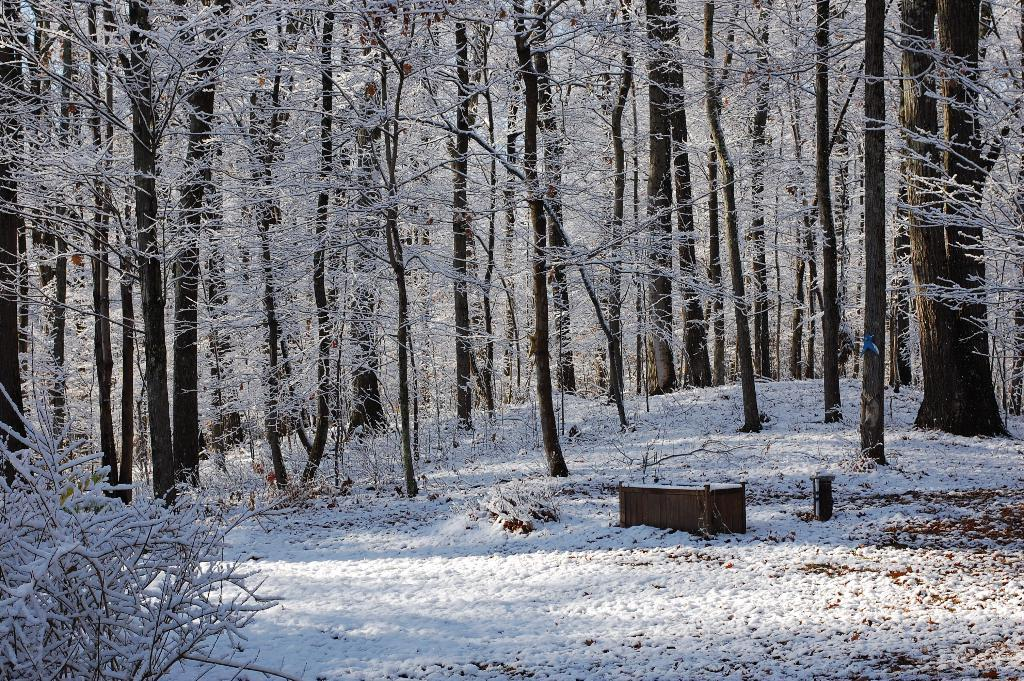What type of vegetation can be seen in the image? There are trees in the image. What is covering the ground in the image? The ground is covered with snow in the image. What is the fireman doing in the image? There is no fireman present in the image. How many times does the person need to pull the lever in the image? There is no lever or person pulling it in the image. 